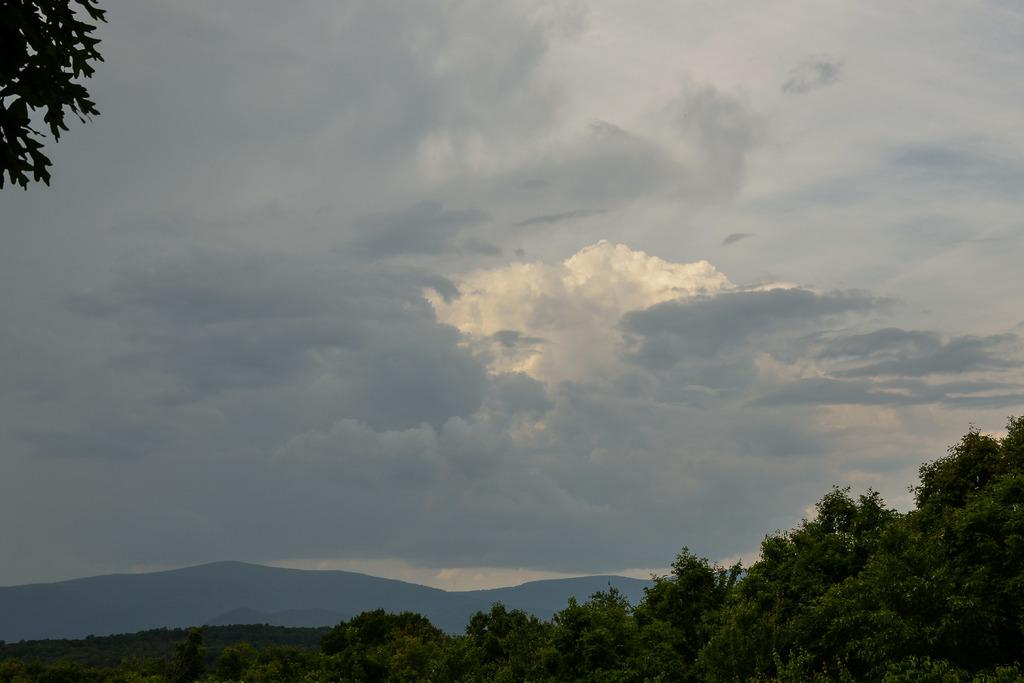What type of vegetation is at the bottom of the image? There are trees at the bottom of the image. What geographical features can be seen in the image? Hills are visible in the image. What is visible at the top of the image? The sky is visible at the top of the image. What class is being taught in the image? There is no class or teaching activity present in the image. Can you see the friend of the person in the image? There is no person or friend depicted in the image; it features trees, hills, and the sky. 